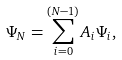Convert formula to latex. <formula><loc_0><loc_0><loc_500><loc_500>\Psi _ { N } = \sum _ { i = 0 } ^ { ( N - 1 ) } A _ { i } \Psi _ { i } ,</formula> 